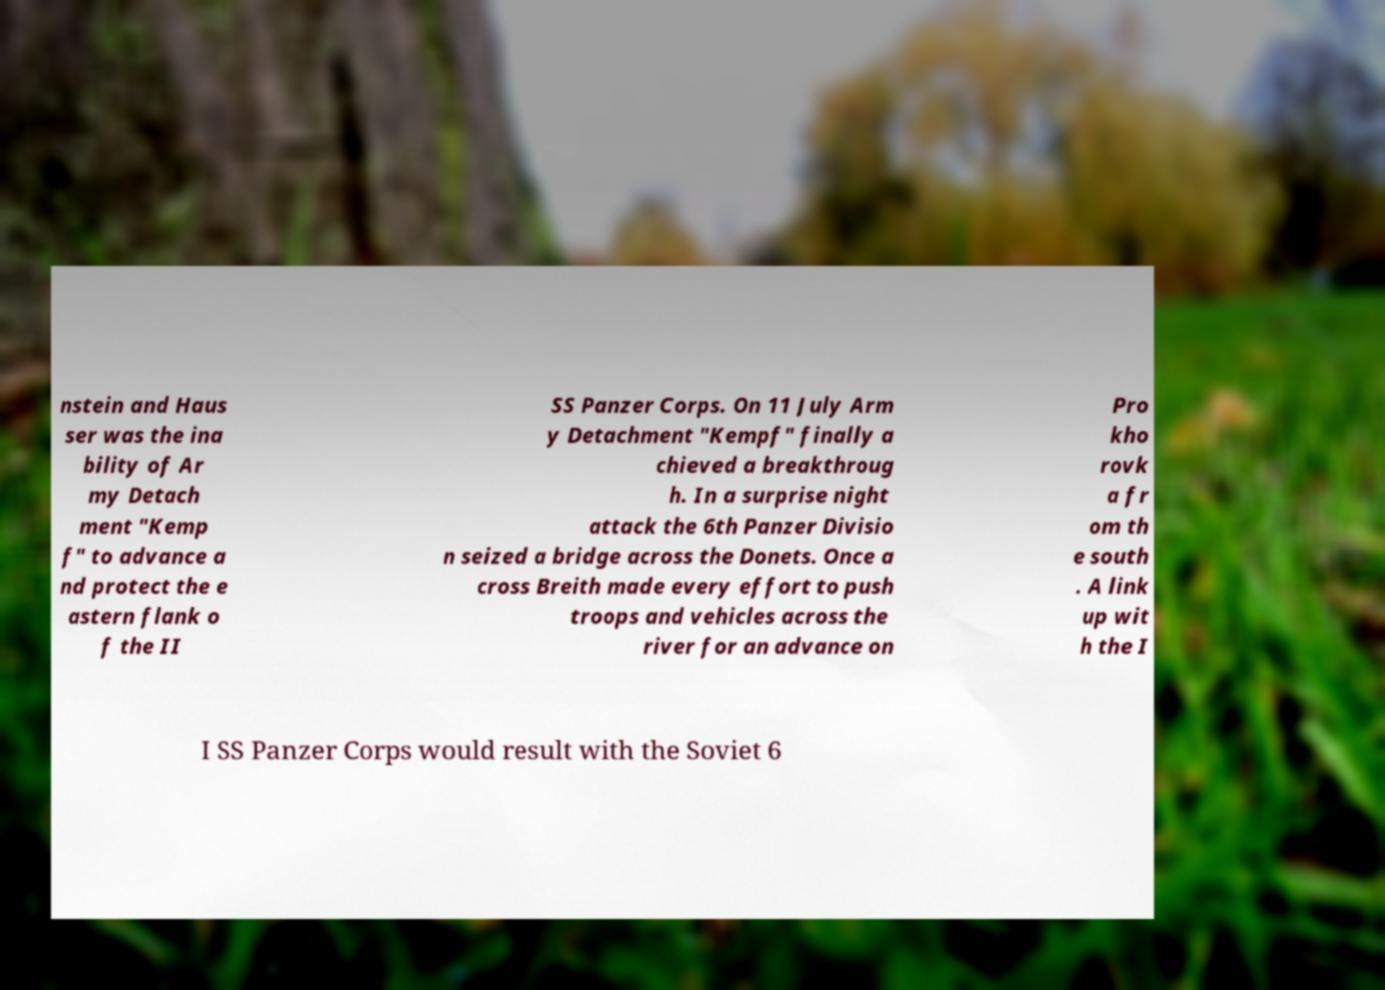There's text embedded in this image that I need extracted. Can you transcribe it verbatim? nstein and Haus ser was the ina bility of Ar my Detach ment "Kemp f" to advance a nd protect the e astern flank o f the II SS Panzer Corps. On 11 July Arm y Detachment "Kempf" finally a chieved a breakthroug h. In a surprise night attack the 6th Panzer Divisio n seized a bridge across the Donets. Once a cross Breith made every effort to push troops and vehicles across the river for an advance on Pro kho rovk a fr om th e south . A link up wit h the I I SS Panzer Corps would result with the Soviet 6 